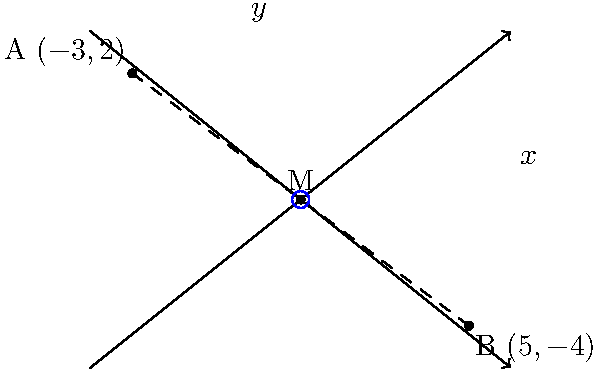In a cosmic design challenge, you're tasked with visualizing a wormhole connecting two distant points in space. Point A represents the entrance at coordinates $(-3, 2)$, and point B represents the exit at $(5, -4)$. To stabilize the wormhole, you need to determine its midpoint M. What are the coordinates of point M? To find the midpoint M of the wormhole connecting points A and B, we'll use the midpoint formula:

$M = (\frac{x_1 + x_2}{2}, \frac{y_1 + y_2}{2})$

Where $(x_1, y_1)$ are the coordinates of point A, and $(x_2, y_2)$ are the coordinates of point B.

Step 1: Identify the coordinates
A $(-3, 2)$
B $(5, -4)$

Step 2: Apply the midpoint formula
$x$ coordinate of M: $\frac{x_1 + x_2}{2} = \frac{-3 + 5}{2} = \frac{2}{2} = 1$
$y$ coordinate of M: $\frac{y_1 + y_2}{2} = \frac{2 + (-4)}{2} = \frac{-2}{2} = -1$

Therefore, the coordinates of the midpoint M are $(1, -1)$.
Answer: $(1, -1)$ 